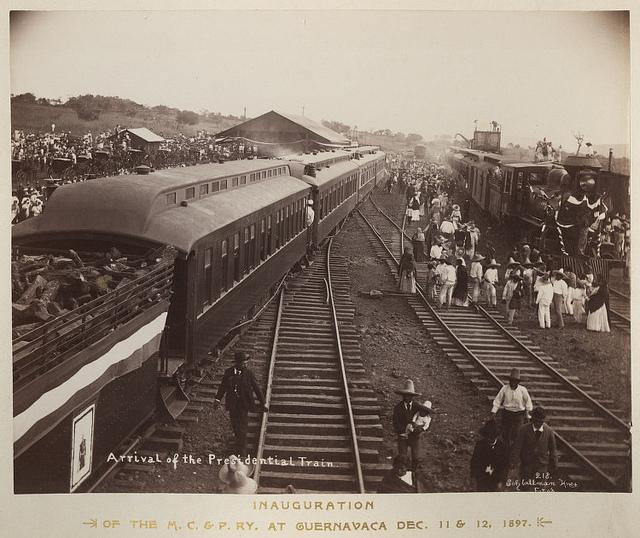How many trains are there?
Short answer required. 2. Has the train arrived for these people?
Keep it brief. Yes. Is this a current photo?
Give a very brief answer. No. Are the metal lines parallel, perpendicular, or neither?
Short answer required. Parallel. What type of train is depicted?
Answer briefly. Passenger. 